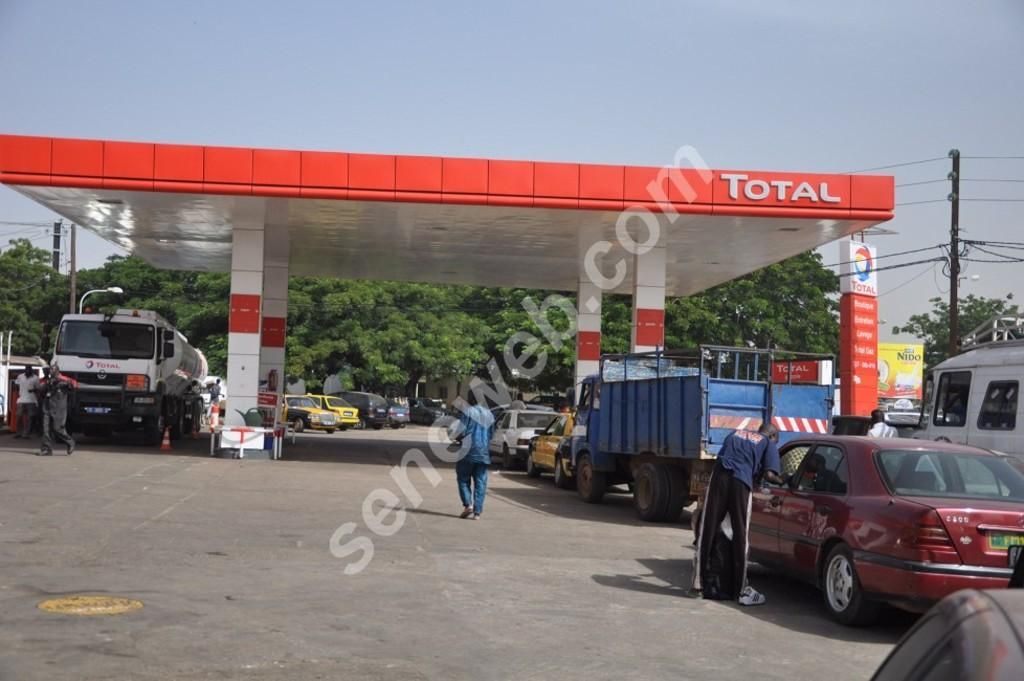<image>
Relay a brief, clear account of the picture shown. People are getting gas at a Total gas station. 